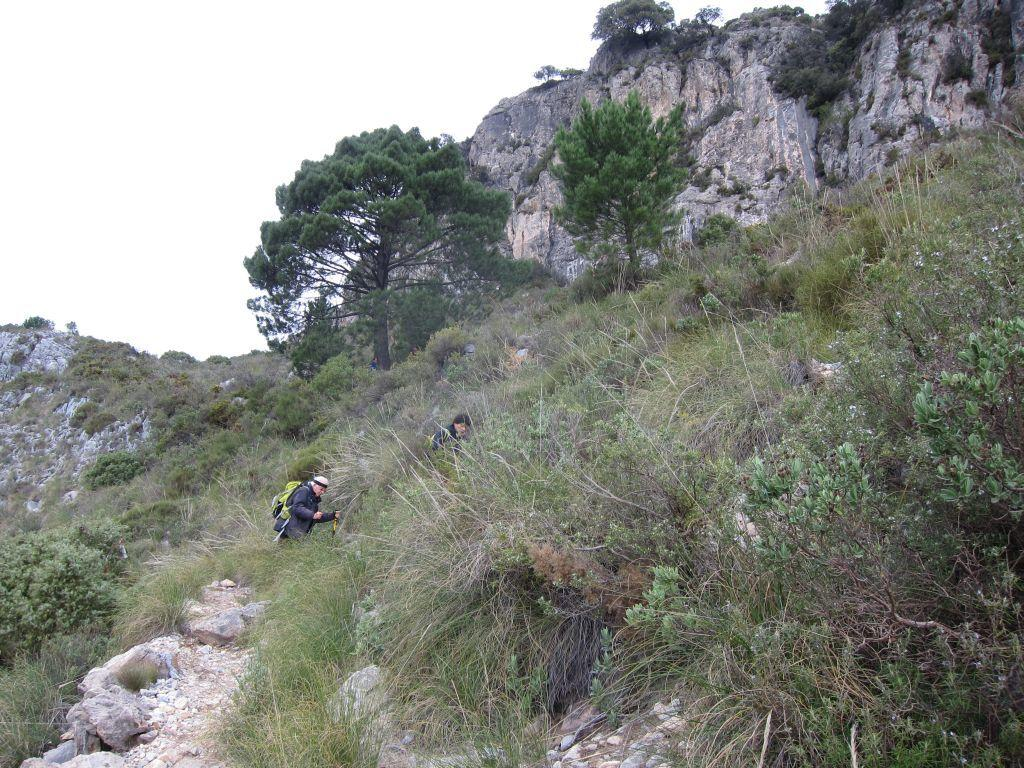What geographical feature is present in the image? There is a hill in the image. What are the two people in the image doing? The two people are walking on the hill. What type of vegetation is visible around the hill? There is a lot of grass around the hill. Can you describe the trees in the image? There are trees in the image. What type of teeth can be seen on the carriage in the image? There is no carriage present in the image, so there are no teeth to be seen. 